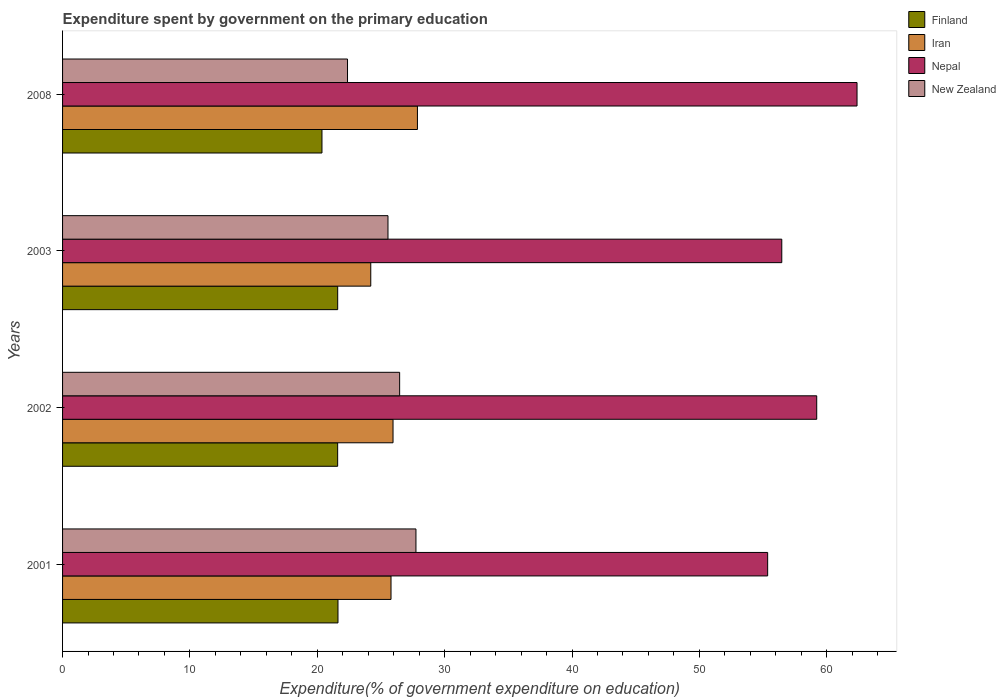How many groups of bars are there?
Your response must be concise. 4. How many bars are there on the 2nd tick from the top?
Give a very brief answer. 4. How many bars are there on the 1st tick from the bottom?
Offer a terse response. 4. What is the expenditure spent by government on the primary education in Iran in 2003?
Give a very brief answer. 24.2. Across all years, what is the maximum expenditure spent by government on the primary education in New Zealand?
Your answer should be very brief. 27.75. Across all years, what is the minimum expenditure spent by government on the primary education in Nepal?
Make the answer very short. 55.36. In which year was the expenditure spent by government on the primary education in Nepal maximum?
Your response must be concise. 2008. What is the total expenditure spent by government on the primary education in Iran in the graph?
Make the answer very short. 103.8. What is the difference between the expenditure spent by government on the primary education in Nepal in 2002 and that in 2008?
Provide a short and direct response. -3.17. What is the difference between the expenditure spent by government on the primary education in Nepal in 2008 and the expenditure spent by government on the primary education in New Zealand in 2003?
Keep it short and to the point. 36.83. What is the average expenditure spent by government on the primary education in New Zealand per year?
Offer a terse response. 25.53. In the year 2003, what is the difference between the expenditure spent by government on the primary education in Iran and expenditure spent by government on the primary education in Nepal?
Offer a terse response. -32.27. What is the ratio of the expenditure spent by government on the primary education in Nepal in 2001 to that in 2002?
Your answer should be compact. 0.93. Is the expenditure spent by government on the primary education in New Zealand in 2002 less than that in 2008?
Provide a short and direct response. No. Is the difference between the expenditure spent by government on the primary education in Iran in 2002 and 2008 greater than the difference between the expenditure spent by government on the primary education in Nepal in 2002 and 2008?
Give a very brief answer. Yes. What is the difference between the highest and the second highest expenditure spent by government on the primary education in New Zealand?
Offer a terse response. 1.28. What is the difference between the highest and the lowest expenditure spent by government on the primary education in Finland?
Your answer should be very brief. 1.26. In how many years, is the expenditure spent by government on the primary education in New Zealand greater than the average expenditure spent by government on the primary education in New Zealand taken over all years?
Give a very brief answer. 3. Is it the case that in every year, the sum of the expenditure spent by government on the primary education in Nepal and expenditure spent by government on the primary education in Iran is greater than the sum of expenditure spent by government on the primary education in New Zealand and expenditure spent by government on the primary education in Finland?
Provide a short and direct response. No. What does the 4th bar from the bottom in 2008 represents?
Provide a succinct answer. New Zealand. Is it the case that in every year, the sum of the expenditure spent by government on the primary education in Nepal and expenditure spent by government on the primary education in Iran is greater than the expenditure spent by government on the primary education in Finland?
Give a very brief answer. Yes. Are all the bars in the graph horizontal?
Ensure brevity in your answer.  Yes. How many years are there in the graph?
Provide a short and direct response. 4. What is the difference between two consecutive major ticks on the X-axis?
Your answer should be compact. 10. Does the graph contain grids?
Your response must be concise. No. How many legend labels are there?
Provide a succinct answer. 4. What is the title of the graph?
Provide a short and direct response. Expenditure spent by government on the primary education. What is the label or title of the X-axis?
Make the answer very short. Expenditure(% of government expenditure on education). What is the label or title of the Y-axis?
Your response must be concise. Years. What is the Expenditure(% of government expenditure on education) of Finland in 2001?
Your response must be concise. 21.62. What is the Expenditure(% of government expenditure on education) in Iran in 2001?
Your answer should be compact. 25.79. What is the Expenditure(% of government expenditure on education) of Nepal in 2001?
Provide a short and direct response. 55.36. What is the Expenditure(% of government expenditure on education) of New Zealand in 2001?
Offer a very short reply. 27.75. What is the Expenditure(% of government expenditure on education) of Finland in 2002?
Your answer should be compact. 21.6. What is the Expenditure(% of government expenditure on education) of Iran in 2002?
Make the answer very short. 25.95. What is the Expenditure(% of government expenditure on education) in Nepal in 2002?
Ensure brevity in your answer.  59.21. What is the Expenditure(% of government expenditure on education) of New Zealand in 2002?
Your response must be concise. 26.47. What is the Expenditure(% of government expenditure on education) in Finland in 2003?
Keep it short and to the point. 21.6. What is the Expenditure(% of government expenditure on education) in Iran in 2003?
Offer a terse response. 24.2. What is the Expenditure(% of government expenditure on education) in Nepal in 2003?
Your answer should be very brief. 56.47. What is the Expenditure(% of government expenditure on education) of New Zealand in 2003?
Offer a terse response. 25.55. What is the Expenditure(% of government expenditure on education) of Finland in 2008?
Provide a short and direct response. 20.37. What is the Expenditure(% of government expenditure on education) of Iran in 2008?
Ensure brevity in your answer.  27.86. What is the Expenditure(% of government expenditure on education) in Nepal in 2008?
Ensure brevity in your answer.  62.38. What is the Expenditure(% of government expenditure on education) in New Zealand in 2008?
Provide a short and direct response. 22.37. Across all years, what is the maximum Expenditure(% of government expenditure on education) in Finland?
Provide a short and direct response. 21.62. Across all years, what is the maximum Expenditure(% of government expenditure on education) in Iran?
Your answer should be very brief. 27.86. Across all years, what is the maximum Expenditure(% of government expenditure on education) of Nepal?
Keep it short and to the point. 62.38. Across all years, what is the maximum Expenditure(% of government expenditure on education) of New Zealand?
Offer a terse response. 27.75. Across all years, what is the minimum Expenditure(% of government expenditure on education) in Finland?
Give a very brief answer. 20.37. Across all years, what is the minimum Expenditure(% of government expenditure on education) in Iran?
Keep it short and to the point. 24.2. Across all years, what is the minimum Expenditure(% of government expenditure on education) of Nepal?
Your answer should be very brief. 55.36. Across all years, what is the minimum Expenditure(% of government expenditure on education) of New Zealand?
Keep it short and to the point. 22.37. What is the total Expenditure(% of government expenditure on education) in Finland in the graph?
Provide a succinct answer. 85.19. What is the total Expenditure(% of government expenditure on education) in Iran in the graph?
Provide a succinct answer. 103.8. What is the total Expenditure(% of government expenditure on education) of Nepal in the graph?
Your answer should be very brief. 233.43. What is the total Expenditure(% of government expenditure on education) in New Zealand in the graph?
Your response must be concise. 102.14. What is the difference between the Expenditure(% of government expenditure on education) in Finland in 2001 and that in 2002?
Offer a very short reply. 0.03. What is the difference between the Expenditure(% of government expenditure on education) in Iran in 2001 and that in 2002?
Give a very brief answer. -0.16. What is the difference between the Expenditure(% of government expenditure on education) in Nepal in 2001 and that in 2002?
Keep it short and to the point. -3.85. What is the difference between the Expenditure(% of government expenditure on education) in New Zealand in 2001 and that in 2002?
Your response must be concise. 1.28. What is the difference between the Expenditure(% of government expenditure on education) of Finland in 2001 and that in 2003?
Make the answer very short. 0.02. What is the difference between the Expenditure(% of government expenditure on education) of Iran in 2001 and that in 2003?
Make the answer very short. 1.59. What is the difference between the Expenditure(% of government expenditure on education) of Nepal in 2001 and that in 2003?
Your answer should be very brief. -1.11. What is the difference between the Expenditure(% of government expenditure on education) of New Zealand in 2001 and that in 2003?
Offer a terse response. 2.2. What is the difference between the Expenditure(% of government expenditure on education) of Finland in 2001 and that in 2008?
Offer a terse response. 1.26. What is the difference between the Expenditure(% of government expenditure on education) in Iran in 2001 and that in 2008?
Your response must be concise. -2.07. What is the difference between the Expenditure(% of government expenditure on education) in Nepal in 2001 and that in 2008?
Offer a very short reply. -7.02. What is the difference between the Expenditure(% of government expenditure on education) of New Zealand in 2001 and that in 2008?
Ensure brevity in your answer.  5.37. What is the difference between the Expenditure(% of government expenditure on education) of Finland in 2002 and that in 2003?
Make the answer very short. -0. What is the difference between the Expenditure(% of government expenditure on education) in Iran in 2002 and that in 2003?
Offer a very short reply. 1.75. What is the difference between the Expenditure(% of government expenditure on education) in Nepal in 2002 and that in 2003?
Make the answer very short. 2.74. What is the difference between the Expenditure(% of government expenditure on education) of New Zealand in 2002 and that in 2003?
Offer a very short reply. 0.91. What is the difference between the Expenditure(% of government expenditure on education) of Finland in 2002 and that in 2008?
Provide a short and direct response. 1.23. What is the difference between the Expenditure(% of government expenditure on education) of Iran in 2002 and that in 2008?
Ensure brevity in your answer.  -1.92. What is the difference between the Expenditure(% of government expenditure on education) in Nepal in 2002 and that in 2008?
Provide a short and direct response. -3.17. What is the difference between the Expenditure(% of government expenditure on education) in New Zealand in 2002 and that in 2008?
Provide a succinct answer. 4.09. What is the difference between the Expenditure(% of government expenditure on education) in Finland in 2003 and that in 2008?
Offer a terse response. 1.23. What is the difference between the Expenditure(% of government expenditure on education) in Iran in 2003 and that in 2008?
Your response must be concise. -3.66. What is the difference between the Expenditure(% of government expenditure on education) of Nepal in 2003 and that in 2008?
Your answer should be very brief. -5.91. What is the difference between the Expenditure(% of government expenditure on education) of New Zealand in 2003 and that in 2008?
Your answer should be compact. 3.18. What is the difference between the Expenditure(% of government expenditure on education) in Finland in 2001 and the Expenditure(% of government expenditure on education) in Iran in 2002?
Provide a succinct answer. -4.32. What is the difference between the Expenditure(% of government expenditure on education) of Finland in 2001 and the Expenditure(% of government expenditure on education) of Nepal in 2002?
Make the answer very short. -37.59. What is the difference between the Expenditure(% of government expenditure on education) of Finland in 2001 and the Expenditure(% of government expenditure on education) of New Zealand in 2002?
Ensure brevity in your answer.  -4.84. What is the difference between the Expenditure(% of government expenditure on education) of Iran in 2001 and the Expenditure(% of government expenditure on education) of Nepal in 2002?
Ensure brevity in your answer.  -33.42. What is the difference between the Expenditure(% of government expenditure on education) in Iran in 2001 and the Expenditure(% of government expenditure on education) in New Zealand in 2002?
Your answer should be compact. -0.68. What is the difference between the Expenditure(% of government expenditure on education) of Nepal in 2001 and the Expenditure(% of government expenditure on education) of New Zealand in 2002?
Give a very brief answer. 28.9. What is the difference between the Expenditure(% of government expenditure on education) in Finland in 2001 and the Expenditure(% of government expenditure on education) in Iran in 2003?
Offer a very short reply. -2.57. What is the difference between the Expenditure(% of government expenditure on education) in Finland in 2001 and the Expenditure(% of government expenditure on education) in Nepal in 2003?
Provide a short and direct response. -34.85. What is the difference between the Expenditure(% of government expenditure on education) in Finland in 2001 and the Expenditure(% of government expenditure on education) in New Zealand in 2003?
Keep it short and to the point. -3.93. What is the difference between the Expenditure(% of government expenditure on education) of Iran in 2001 and the Expenditure(% of government expenditure on education) of Nepal in 2003?
Provide a short and direct response. -30.68. What is the difference between the Expenditure(% of government expenditure on education) of Iran in 2001 and the Expenditure(% of government expenditure on education) of New Zealand in 2003?
Make the answer very short. 0.24. What is the difference between the Expenditure(% of government expenditure on education) in Nepal in 2001 and the Expenditure(% of government expenditure on education) in New Zealand in 2003?
Your answer should be compact. 29.81. What is the difference between the Expenditure(% of government expenditure on education) in Finland in 2001 and the Expenditure(% of government expenditure on education) in Iran in 2008?
Provide a succinct answer. -6.24. What is the difference between the Expenditure(% of government expenditure on education) of Finland in 2001 and the Expenditure(% of government expenditure on education) of Nepal in 2008?
Offer a very short reply. -40.75. What is the difference between the Expenditure(% of government expenditure on education) of Finland in 2001 and the Expenditure(% of government expenditure on education) of New Zealand in 2008?
Provide a succinct answer. -0.75. What is the difference between the Expenditure(% of government expenditure on education) of Iran in 2001 and the Expenditure(% of government expenditure on education) of Nepal in 2008?
Provide a short and direct response. -36.59. What is the difference between the Expenditure(% of government expenditure on education) of Iran in 2001 and the Expenditure(% of government expenditure on education) of New Zealand in 2008?
Your answer should be very brief. 3.42. What is the difference between the Expenditure(% of government expenditure on education) in Nepal in 2001 and the Expenditure(% of government expenditure on education) in New Zealand in 2008?
Offer a terse response. 32.99. What is the difference between the Expenditure(% of government expenditure on education) in Finland in 2002 and the Expenditure(% of government expenditure on education) in Iran in 2003?
Make the answer very short. -2.6. What is the difference between the Expenditure(% of government expenditure on education) of Finland in 2002 and the Expenditure(% of government expenditure on education) of Nepal in 2003?
Keep it short and to the point. -34.87. What is the difference between the Expenditure(% of government expenditure on education) of Finland in 2002 and the Expenditure(% of government expenditure on education) of New Zealand in 2003?
Your response must be concise. -3.95. What is the difference between the Expenditure(% of government expenditure on education) of Iran in 2002 and the Expenditure(% of government expenditure on education) of Nepal in 2003?
Provide a short and direct response. -30.52. What is the difference between the Expenditure(% of government expenditure on education) in Iran in 2002 and the Expenditure(% of government expenditure on education) in New Zealand in 2003?
Offer a terse response. 0.4. What is the difference between the Expenditure(% of government expenditure on education) of Nepal in 2002 and the Expenditure(% of government expenditure on education) of New Zealand in 2003?
Your answer should be very brief. 33.66. What is the difference between the Expenditure(% of government expenditure on education) of Finland in 2002 and the Expenditure(% of government expenditure on education) of Iran in 2008?
Your response must be concise. -6.26. What is the difference between the Expenditure(% of government expenditure on education) in Finland in 2002 and the Expenditure(% of government expenditure on education) in Nepal in 2008?
Make the answer very short. -40.78. What is the difference between the Expenditure(% of government expenditure on education) of Finland in 2002 and the Expenditure(% of government expenditure on education) of New Zealand in 2008?
Offer a terse response. -0.77. What is the difference between the Expenditure(% of government expenditure on education) in Iran in 2002 and the Expenditure(% of government expenditure on education) in Nepal in 2008?
Your answer should be very brief. -36.43. What is the difference between the Expenditure(% of government expenditure on education) in Iran in 2002 and the Expenditure(% of government expenditure on education) in New Zealand in 2008?
Your answer should be very brief. 3.57. What is the difference between the Expenditure(% of government expenditure on education) in Nepal in 2002 and the Expenditure(% of government expenditure on education) in New Zealand in 2008?
Provide a succinct answer. 36.84. What is the difference between the Expenditure(% of government expenditure on education) of Finland in 2003 and the Expenditure(% of government expenditure on education) of Iran in 2008?
Ensure brevity in your answer.  -6.26. What is the difference between the Expenditure(% of government expenditure on education) in Finland in 2003 and the Expenditure(% of government expenditure on education) in Nepal in 2008?
Give a very brief answer. -40.78. What is the difference between the Expenditure(% of government expenditure on education) of Finland in 2003 and the Expenditure(% of government expenditure on education) of New Zealand in 2008?
Ensure brevity in your answer.  -0.77. What is the difference between the Expenditure(% of government expenditure on education) of Iran in 2003 and the Expenditure(% of government expenditure on education) of Nepal in 2008?
Ensure brevity in your answer.  -38.18. What is the difference between the Expenditure(% of government expenditure on education) in Iran in 2003 and the Expenditure(% of government expenditure on education) in New Zealand in 2008?
Ensure brevity in your answer.  1.83. What is the difference between the Expenditure(% of government expenditure on education) in Nepal in 2003 and the Expenditure(% of government expenditure on education) in New Zealand in 2008?
Provide a short and direct response. 34.1. What is the average Expenditure(% of government expenditure on education) in Finland per year?
Your answer should be very brief. 21.3. What is the average Expenditure(% of government expenditure on education) in Iran per year?
Offer a terse response. 25.95. What is the average Expenditure(% of government expenditure on education) in Nepal per year?
Offer a very short reply. 58.36. What is the average Expenditure(% of government expenditure on education) in New Zealand per year?
Offer a terse response. 25.53. In the year 2001, what is the difference between the Expenditure(% of government expenditure on education) in Finland and Expenditure(% of government expenditure on education) in Iran?
Make the answer very short. -4.16. In the year 2001, what is the difference between the Expenditure(% of government expenditure on education) of Finland and Expenditure(% of government expenditure on education) of Nepal?
Keep it short and to the point. -33.74. In the year 2001, what is the difference between the Expenditure(% of government expenditure on education) of Finland and Expenditure(% of government expenditure on education) of New Zealand?
Your response must be concise. -6.12. In the year 2001, what is the difference between the Expenditure(% of government expenditure on education) of Iran and Expenditure(% of government expenditure on education) of Nepal?
Your answer should be compact. -29.57. In the year 2001, what is the difference between the Expenditure(% of government expenditure on education) in Iran and Expenditure(% of government expenditure on education) in New Zealand?
Offer a very short reply. -1.96. In the year 2001, what is the difference between the Expenditure(% of government expenditure on education) of Nepal and Expenditure(% of government expenditure on education) of New Zealand?
Keep it short and to the point. 27.62. In the year 2002, what is the difference between the Expenditure(% of government expenditure on education) in Finland and Expenditure(% of government expenditure on education) in Iran?
Your answer should be compact. -4.35. In the year 2002, what is the difference between the Expenditure(% of government expenditure on education) in Finland and Expenditure(% of government expenditure on education) in Nepal?
Your answer should be compact. -37.61. In the year 2002, what is the difference between the Expenditure(% of government expenditure on education) in Finland and Expenditure(% of government expenditure on education) in New Zealand?
Your response must be concise. -4.87. In the year 2002, what is the difference between the Expenditure(% of government expenditure on education) in Iran and Expenditure(% of government expenditure on education) in Nepal?
Make the answer very short. -33.27. In the year 2002, what is the difference between the Expenditure(% of government expenditure on education) of Iran and Expenditure(% of government expenditure on education) of New Zealand?
Your response must be concise. -0.52. In the year 2002, what is the difference between the Expenditure(% of government expenditure on education) in Nepal and Expenditure(% of government expenditure on education) in New Zealand?
Your answer should be very brief. 32.75. In the year 2003, what is the difference between the Expenditure(% of government expenditure on education) in Finland and Expenditure(% of government expenditure on education) in Iran?
Your answer should be compact. -2.6. In the year 2003, what is the difference between the Expenditure(% of government expenditure on education) in Finland and Expenditure(% of government expenditure on education) in Nepal?
Offer a very short reply. -34.87. In the year 2003, what is the difference between the Expenditure(% of government expenditure on education) of Finland and Expenditure(% of government expenditure on education) of New Zealand?
Make the answer very short. -3.95. In the year 2003, what is the difference between the Expenditure(% of government expenditure on education) of Iran and Expenditure(% of government expenditure on education) of Nepal?
Provide a short and direct response. -32.27. In the year 2003, what is the difference between the Expenditure(% of government expenditure on education) of Iran and Expenditure(% of government expenditure on education) of New Zealand?
Provide a succinct answer. -1.35. In the year 2003, what is the difference between the Expenditure(% of government expenditure on education) of Nepal and Expenditure(% of government expenditure on education) of New Zealand?
Offer a very short reply. 30.92. In the year 2008, what is the difference between the Expenditure(% of government expenditure on education) in Finland and Expenditure(% of government expenditure on education) in Iran?
Provide a short and direct response. -7.5. In the year 2008, what is the difference between the Expenditure(% of government expenditure on education) of Finland and Expenditure(% of government expenditure on education) of Nepal?
Your response must be concise. -42.01. In the year 2008, what is the difference between the Expenditure(% of government expenditure on education) in Finland and Expenditure(% of government expenditure on education) in New Zealand?
Make the answer very short. -2.01. In the year 2008, what is the difference between the Expenditure(% of government expenditure on education) in Iran and Expenditure(% of government expenditure on education) in Nepal?
Make the answer very short. -34.52. In the year 2008, what is the difference between the Expenditure(% of government expenditure on education) in Iran and Expenditure(% of government expenditure on education) in New Zealand?
Your answer should be very brief. 5.49. In the year 2008, what is the difference between the Expenditure(% of government expenditure on education) in Nepal and Expenditure(% of government expenditure on education) in New Zealand?
Offer a very short reply. 40.01. What is the ratio of the Expenditure(% of government expenditure on education) of Finland in 2001 to that in 2002?
Give a very brief answer. 1. What is the ratio of the Expenditure(% of government expenditure on education) in Nepal in 2001 to that in 2002?
Make the answer very short. 0.94. What is the ratio of the Expenditure(% of government expenditure on education) of New Zealand in 2001 to that in 2002?
Ensure brevity in your answer.  1.05. What is the ratio of the Expenditure(% of government expenditure on education) in Finland in 2001 to that in 2003?
Keep it short and to the point. 1. What is the ratio of the Expenditure(% of government expenditure on education) of Iran in 2001 to that in 2003?
Your answer should be very brief. 1.07. What is the ratio of the Expenditure(% of government expenditure on education) in Nepal in 2001 to that in 2003?
Provide a short and direct response. 0.98. What is the ratio of the Expenditure(% of government expenditure on education) of New Zealand in 2001 to that in 2003?
Keep it short and to the point. 1.09. What is the ratio of the Expenditure(% of government expenditure on education) in Finland in 2001 to that in 2008?
Provide a succinct answer. 1.06. What is the ratio of the Expenditure(% of government expenditure on education) of Iran in 2001 to that in 2008?
Offer a very short reply. 0.93. What is the ratio of the Expenditure(% of government expenditure on education) in Nepal in 2001 to that in 2008?
Make the answer very short. 0.89. What is the ratio of the Expenditure(% of government expenditure on education) of New Zealand in 2001 to that in 2008?
Provide a short and direct response. 1.24. What is the ratio of the Expenditure(% of government expenditure on education) of Finland in 2002 to that in 2003?
Your response must be concise. 1. What is the ratio of the Expenditure(% of government expenditure on education) in Iran in 2002 to that in 2003?
Provide a succinct answer. 1.07. What is the ratio of the Expenditure(% of government expenditure on education) of Nepal in 2002 to that in 2003?
Your answer should be compact. 1.05. What is the ratio of the Expenditure(% of government expenditure on education) of New Zealand in 2002 to that in 2003?
Your answer should be compact. 1.04. What is the ratio of the Expenditure(% of government expenditure on education) in Finland in 2002 to that in 2008?
Offer a terse response. 1.06. What is the ratio of the Expenditure(% of government expenditure on education) of Iran in 2002 to that in 2008?
Make the answer very short. 0.93. What is the ratio of the Expenditure(% of government expenditure on education) of Nepal in 2002 to that in 2008?
Your answer should be compact. 0.95. What is the ratio of the Expenditure(% of government expenditure on education) of New Zealand in 2002 to that in 2008?
Ensure brevity in your answer.  1.18. What is the ratio of the Expenditure(% of government expenditure on education) of Finland in 2003 to that in 2008?
Offer a terse response. 1.06. What is the ratio of the Expenditure(% of government expenditure on education) in Iran in 2003 to that in 2008?
Give a very brief answer. 0.87. What is the ratio of the Expenditure(% of government expenditure on education) in Nepal in 2003 to that in 2008?
Keep it short and to the point. 0.91. What is the ratio of the Expenditure(% of government expenditure on education) in New Zealand in 2003 to that in 2008?
Make the answer very short. 1.14. What is the difference between the highest and the second highest Expenditure(% of government expenditure on education) of Finland?
Your answer should be compact. 0.02. What is the difference between the highest and the second highest Expenditure(% of government expenditure on education) in Iran?
Provide a short and direct response. 1.92. What is the difference between the highest and the second highest Expenditure(% of government expenditure on education) in Nepal?
Keep it short and to the point. 3.17. What is the difference between the highest and the second highest Expenditure(% of government expenditure on education) of New Zealand?
Your response must be concise. 1.28. What is the difference between the highest and the lowest Expenditure(% of government expenditure on education) of Finland?
Your answer should be very brief. 1.26. What is the difference between the highest and the lowest Expenditure(% of government expenditure on education) in Iran?
Give a very brief answer. 3.66. What is the difference between the highest and the lowest Expenditure(% of government expenditure on education) in Nepal?
Offer a very short reply. 7.02. What is the difference between the highest and the lowest Expenditure(% of government expenditure on education) of New Zealand?
Ensure brevity in your answer.  5.37. 